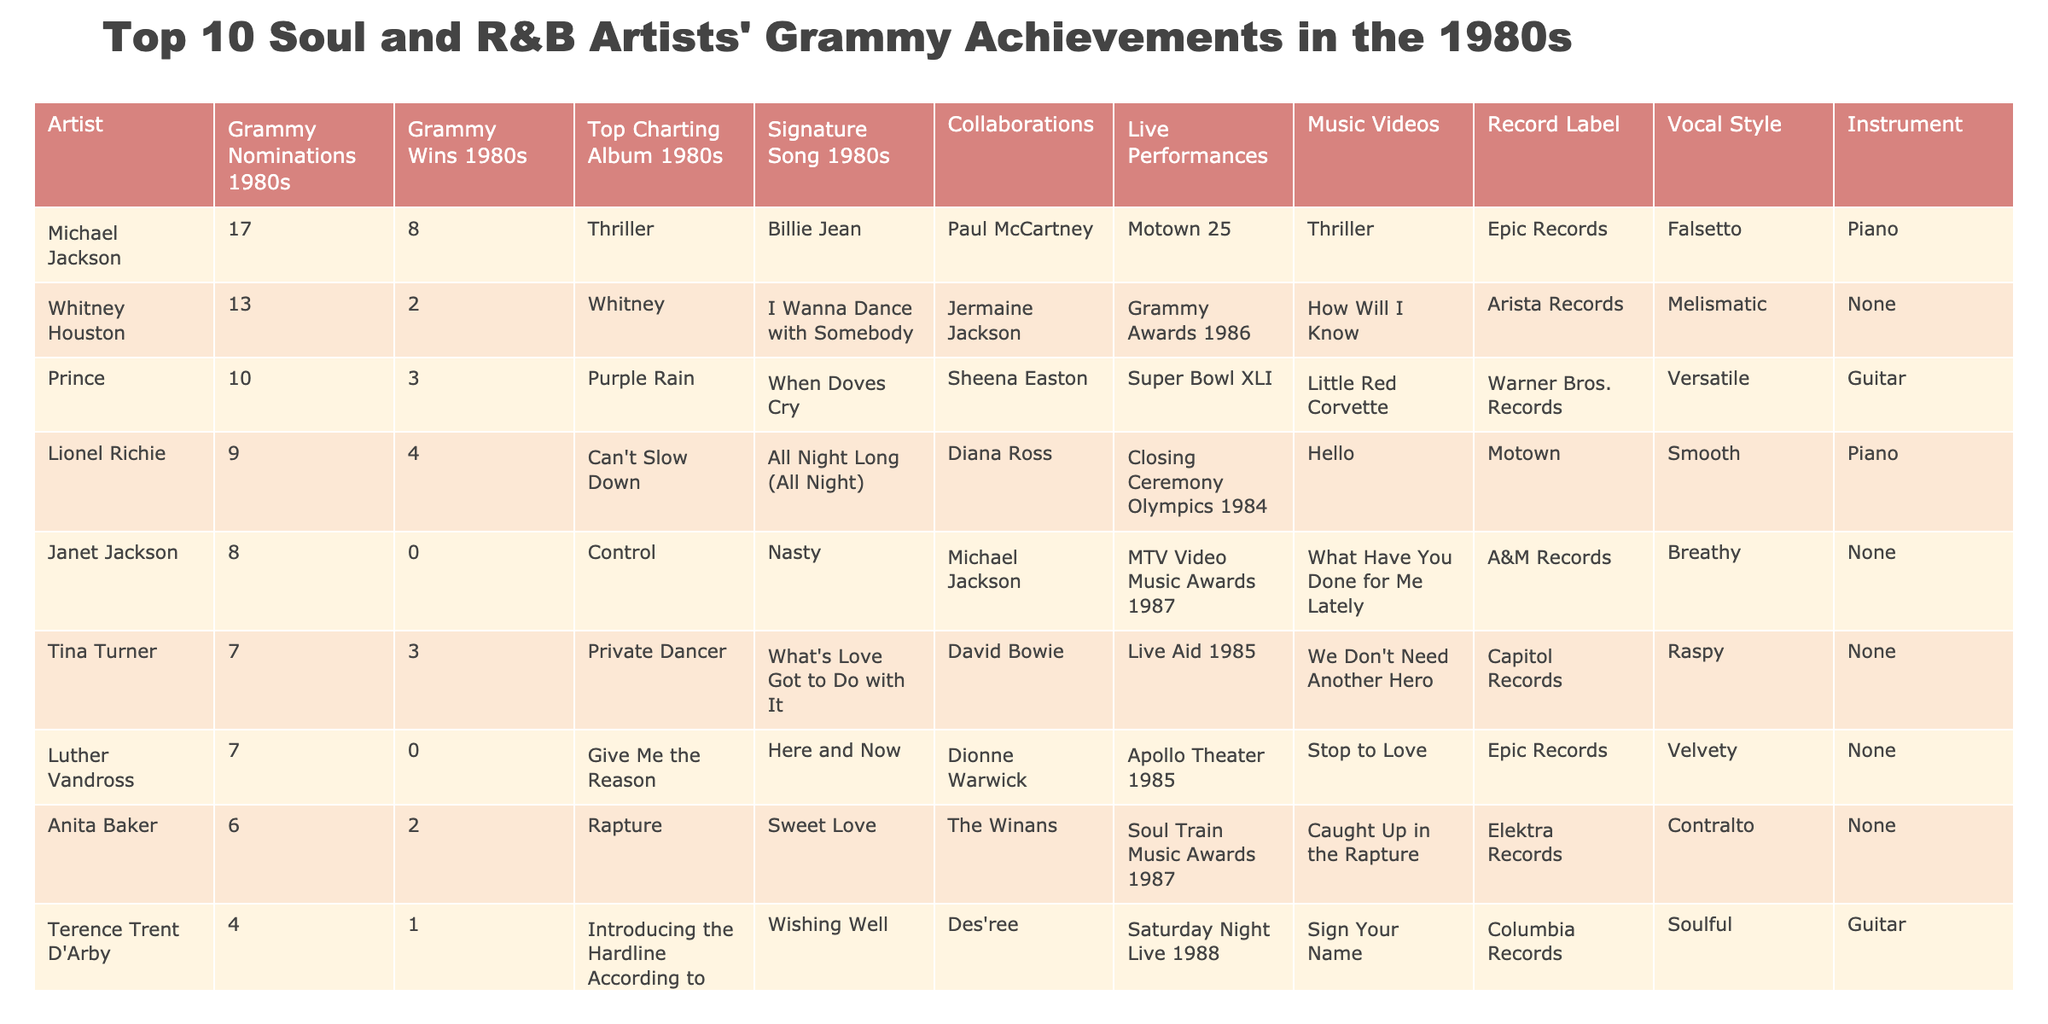What artist had the highest number of Grammy nominations in the 1980s? Michael Jackson has the highest number of nominations with a total of 17, as listed in the table.
Answer: Michael Jackson How many Grammy wins did Prince achieve in the 1980s? Prince won a total of 3 Grammy awards during the 1980s, which is directly stated in the table.
Answer: 3 Which artist had a Grammy win but no nominations listed? Luther Vandross had no Grammy nominations in the 1980s and hence no wins, which is clear from the data presented.
Answer: False Which artist has a higher number of Grammy wins: Sade or Janet Jackson? Sade has 1 Grammy win while Janet Jackson has 0. Since 1 is greater than 0, Sade has more wins.
Answer: Sade What is the average number of Grammy wins for the top 10 artists listed? The total number of wins is 8 + 2 + 3 + 4 + 0 + 3 + 0 + 2 + 1 + 1 = 24. Dividing this by the number of artists (10) gives an average of 2.4.
Answer: 2.4 Did any artist achieve more than 4 wins in the 1980s? By reviewing the win totals, Michael Jackson (8) and Lionel Richie (4) both achieved 4 or more wins, so the statement is true.
Answer: True Which artist had the highest Grammy nominations but the least wins? Janet Jackson had 8 nominations but 0 wins, which is less than any other artist with that number of nominations.
Answer: Janet Jackson What was the top charting album for Terence Trent D'Arby? According to the table, Terence Trent D'Arby's top charting album in the 1980s was "Introducing the Hardline According to Terence Trent D'Arby."
Answer: Introducing the Hardline According to Terence Trent D'Arby How many more Grammy nominations did Michael Jackson have compared to Anita Baker? Michael Jackson had 17 nominations while Anita Baker had 6, so 17 - 6 = 11 more nominations.
Answer: 11 What percentage of artists listed won a Grammy award? Out of 10 artists, 6 won at least 1 Grammy award, so the percentage is (6/10) * 100 = 60%.
Answer: 60% 